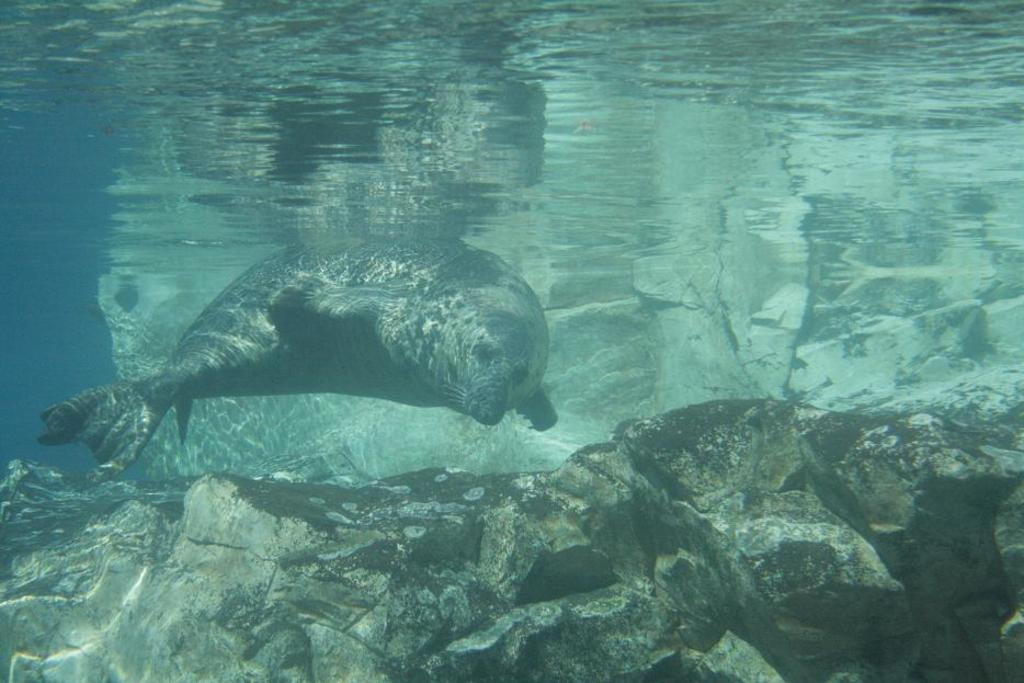What type of animal is in the water in the image? There is a seal animal in the water in the image. What else can be seen at the bottom of the water in the image? There are objects that look like rocks in the water at the bottom of the image. What type of food is the seal eating in the image? There is no food visible in the image, and the seal is not shown eating anything. 